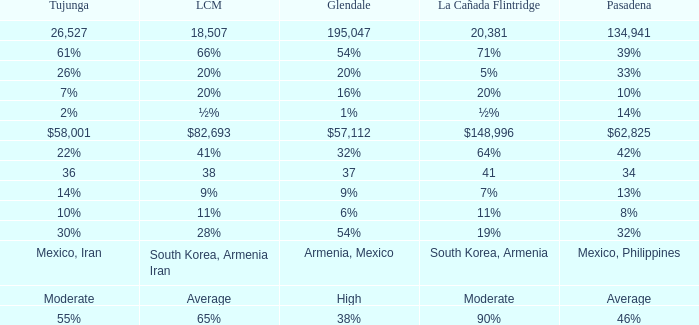What is the percentage of Tukunga when La Crescenta-Montrose is 28%? 30%. 